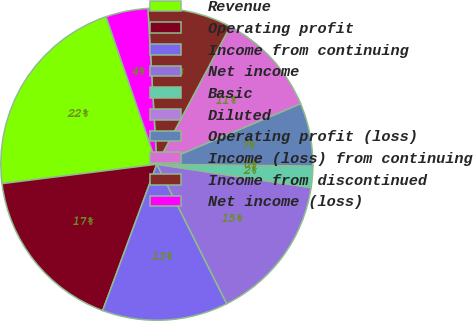<chart> <loc_0><loc_0><loc_500><loc_500><pie_chart><fcel>Revenue<fcel>Operating profit<fcel>Income from continuing<fcel>Net income<fcel>Basic<fcel>Diluted<fcel>Operating profit (loss)<fcel>Income (loss) from continuing<fcel>Income from discontinued<fcel>Net income (loss)<nl><fcel>21.72%<fcel>17.38%<fcel>13.04%<fcel>15.21%<fcel>2.19%<fcel>0.02%<fcel>6.53%<fcel>10.87%<fcel>8.7%<fcel>4.36%<nl></chart> 